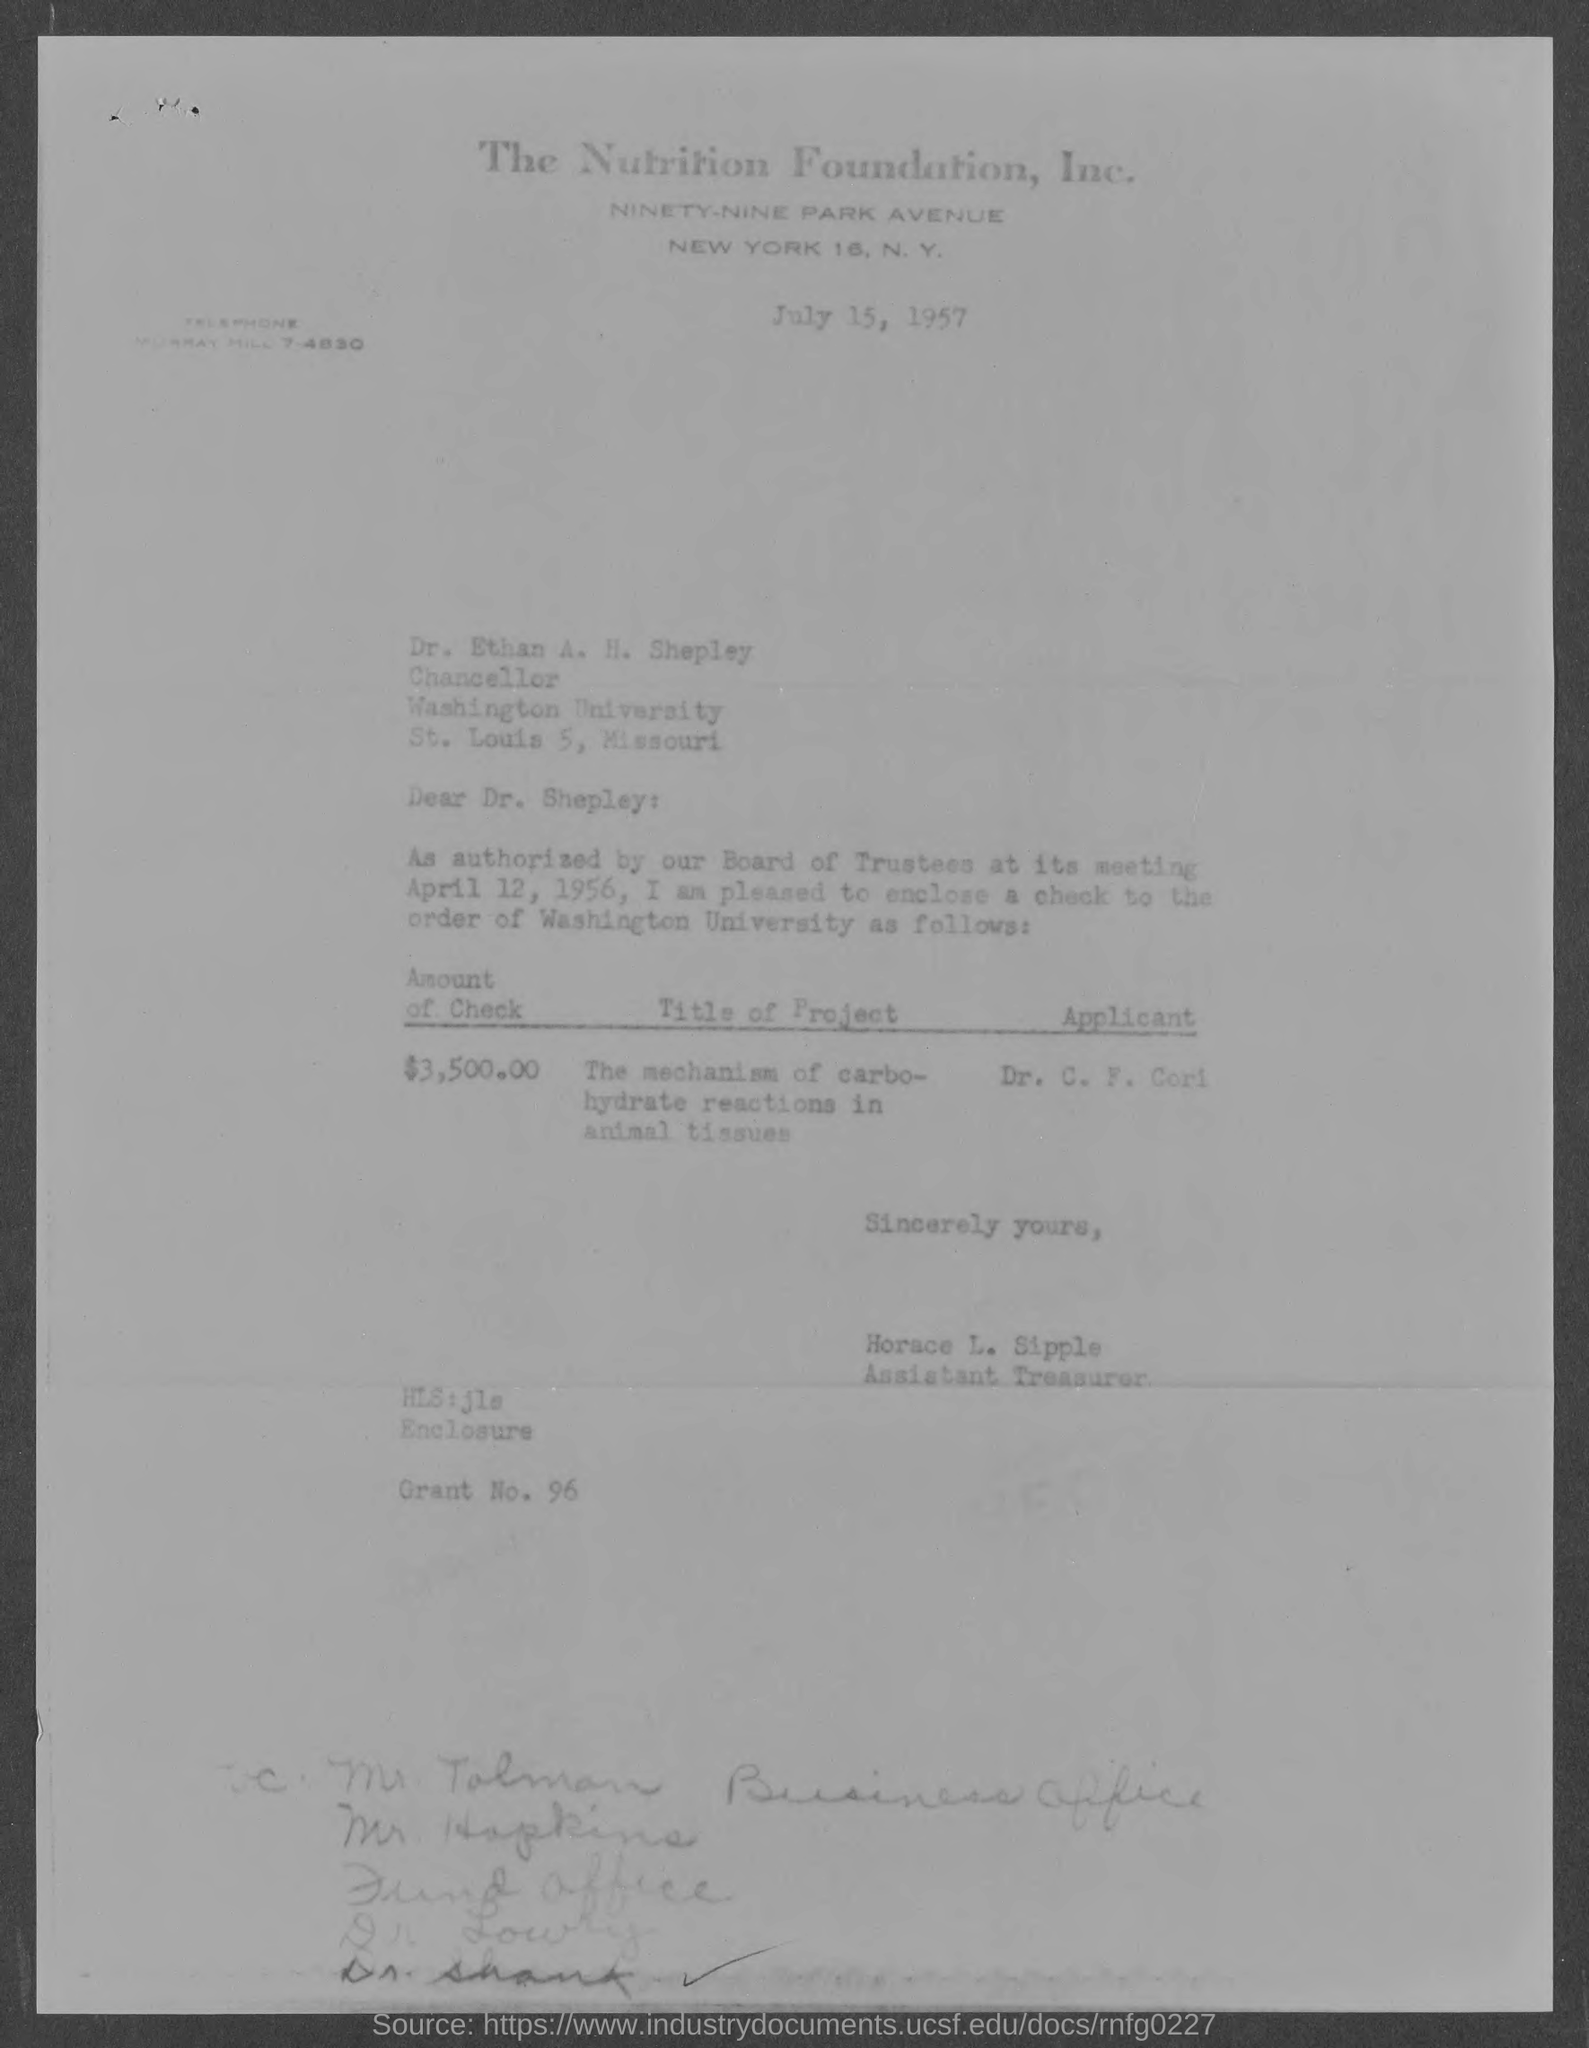Identify some key points in this picture. The title of the project mentioned in the given letter is "The Mechanism of Carbohydrate Reactions in Animal Tissues. Please indicate the grant number mentioned in the provided letter, which is 96... The amount of the check specified in the letter is $3,500.00. 